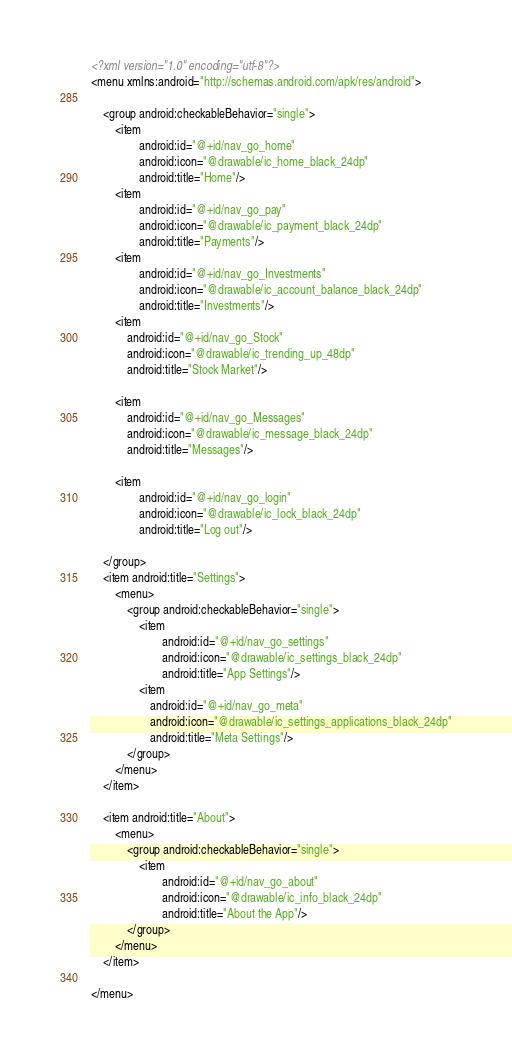<code> <loc_0><loc_0><loc_500><loc_500><_XML_><?xml version="1.0" encoding="utf-8"?>
<menu xmlns:android="http://schemas.android.com/apk/res/android">

    <group android:checkableBehavior="single">
        <item
                android:id="@+id/nav_go_home"
                android:icon="@drawable/ic_home_black_24dp"
                android:title="Home"/>
        <item
                android:id="@+id/nav_go_pay"
                android:icon="@drawable/ic_payment_black_24dp"
                android:title="Payments"/>
        <item
                android:id="@+id/nav_go_Investments"
                android:icon="@drawable/ic_account_balance_black_24dp"
                android:title="Investments"/>
        <item
            android:id="@+id/nav_go_Stock"
            android:icon="@drawable/ic_trending_up_48dp"
            android:title="Stock Market"/>

        <item
            android:id="@+id/nav_go_Messages"
            android:icon="@drawable/ic_message_black_24dp"
            android:title="Messages"/>

        <item
                android:id="@+id/nav_go_login"
                android:icon="@drawable/ic_lock_black_24dp"
                android:title="Log out"/>

    </group>
    <item android:title="Settings">
        <menu>
            <group android:checkableBehavior="single">
                <item
                        android:id="@+id/nav_go_settings"
                        android:icon="@drawable/ic_settings_black_24dp"
                        android:title="App Settings"/>
                <item
                    android:id="@+id/nav_go_meta"
                    android:icon="@drawable/ic_settings_applications_black_24dp"
                    android:title="Meta Settings"/>
            </group>
        </menu>
    </item>

    <item android:title="About">
        <menu>
            <group android:checkableBehavior="single">
                <item
                        android:id="@+id/nav_go_about"
                        android:icon="@drawable/ic_info_black_24dp"
                        android:title="About the App"/>
            </group>
        </menu>
    </item>

</menu>
</code> 